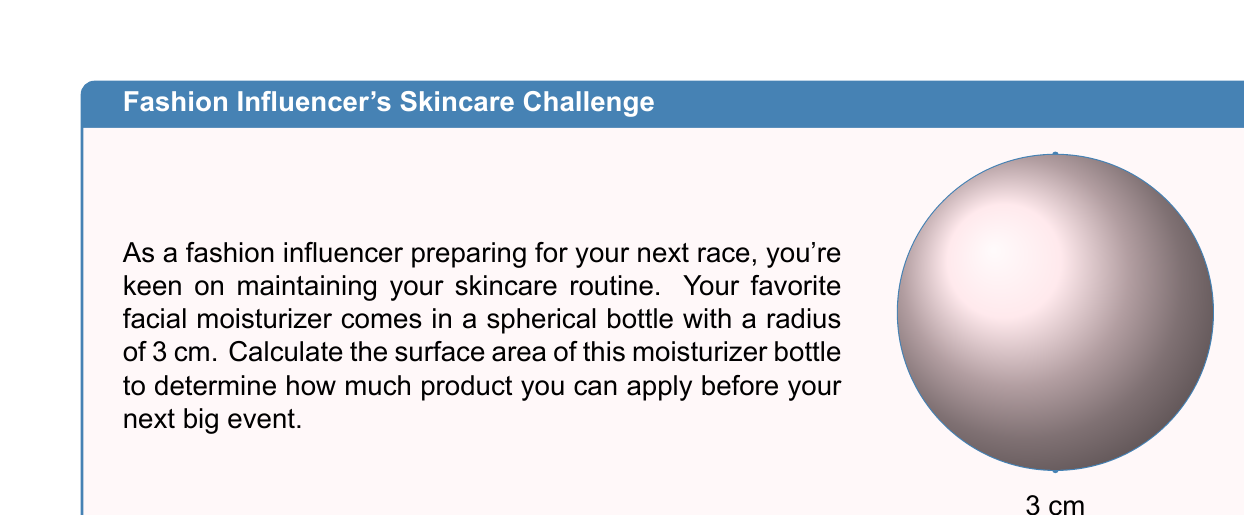What is the answer to this math problem? To calculate the surface area of a sphere, we use the formula:

$$A = 4\pi r^2$$

Where:
$A$ = surface area
$r$ = radius of the sphere

Given:
$r = 3$ cm

Let's substitute this into our formula:

$$\begin{align}
A &= 4\pi r^2 \\
&= 4\pi (3\text{ cm})^2 \\
&= 4\pi (9\text{ cm}^2) \\
&= 36\pi\text{ cm}^2
\end{align}$$

To get the final numerical value, we can use $\pi \approx 3.14159$:

$$\begin{align}
A &\approx 36 \times 3.14159\text{ cm}^2 \\
&\approx 113.09724\text{ cm}^2
\end{align}$$

Rounding to two decimal places for practical use:

$$A \approx 113.10\text{ cm}^2$$

This is the total surface area of your spherical moisturizer bottle.
Answer: $113.10\text{ cm}^2$ 